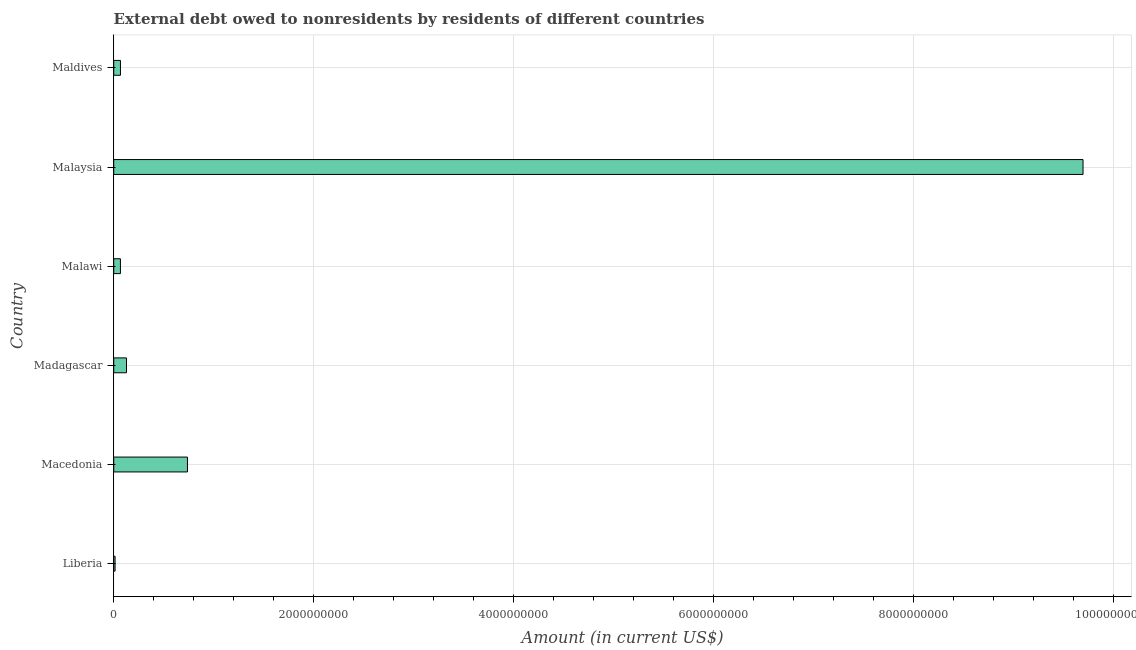Does the graph contain any zero values?
Your answer should be compact. No. What is the title of the graph?
Provide a succinct answer. External debt owed to nonresidents by residents of different countries. What is the label or title of the X-axis?
Make the answer very short. Amount (in current US$). What is the debt in Liberia?
Keep it short and to the point. 1.33e+07. Across all countries, what is the maximum debt?
Provide a short and direct response. 9.70e+09. Across all countries, what is the minimum debt?
Provide a succinct answer. 1.33e+07. In which country was the debt maximum?
Offer a very short reply. Malaysia. In which country was the debt minimum?
Offer a very short reply. Liberia. What is the sum of the debt?
Provide a succinct answer. 1.07e+1. What is the difference between the debt in Macedonia and Maldives?
Keep it short and to the point. 6.70e+08. What is the average debt per country?
Offer a terse response. 1.79e+09. What is the median debt?
Give a very brief answer. 9.73e+07. In how many countries, is the debt greater than 9600000000 US$?
Your response must be concise. 1. What is the ratio of the debt in Macedonia to that in Madagascar?
Keep it short and to the point. 5.79. Is the debt in Liberia less than that in Malaysia?
Your answer should be very brief. Yes. Is the difference between the debt in Madagascar and Maldives greater than the difference between any two countries?
Make the answer very short. No. What is the difference between the highest and the second highest debt?
Provide a short and direct response. 8.96e+09. What is the difference between the highest and the lowest debt?
Offer a terse response. 9.68e+09. What is the difference between two consecutive major ticks on the X-axis?
Give a very brief answer. 2.00e+09. What is the Amount (in current US$) in Liberia?
Provide a succinct answer. 1.33e+07. What is the Amount (in current US$) in Macedonia?
Your answer should be very brief. 7.37e+08. What is the Amount (in current US$) of Madagascar?
Your answer should be compact. 1.27e+08. What is the Amount (in current US$) in Malawi?
Make the answer very short. 6.69e+07. What is the Amount (in current US$) of Malaysia?
Your response must be concise. 9.70e+09. What is the Amount (in current US$) of Maldives?
Provide a succinct answer. 6.72e+07. What is the difference between the Amount (in current US$) in Liberia and Macedonia?
Make the answer very short. -7.24e+08. What is the difference between the Amount (in current US$) in Liberia and Madagascar?
Your answer should be very brief. -1.14e+08. What is the difference between the Amount (in current US$) in Liberia and Malawi?
Provide a succinct answer. -5.35e+07. What is the difference between the Amount (in current US$) in Liberia and Malaysia?
Your response must be concise. -9.68e+09. What is the difference between the Amount (in current US$) in Liberia and Maldives?
Your answer should be very brief. -5.39e+07. What is the difference between the Amount (in current US$) in Macedonia and Madagascar?
Your response must be concise. 6.10e+08. What is the difference between the Amount (in current US$) in Macedonia and Malawi?
Provide a succinct answer. 6.71e+08. What is the difference between the Amount (in current US$) in Macedonia and Malaysia?
Make the answer very short. -8.96e+09. What is the difference between the Amount (in current US$) in Macedonia and Maldives?
Ensure brevity in your answer.  6.70e+08. What is the difference between the Amount (in current US$) in Madagascar and Malawi?
Give a very brief answer. 6.05e+07. What is the difference between the Amount (in current US$) in Madagascar and Malaysia?
Keep it short and to the point. -9.57e+09. What is the difference between the Amount (in current US$) in Madagascar and Maldives?
Keep it short and to the point. 6.02e+07. What is the difference between the Amount (in current US$) in Malawi and Malaysia?
Offer a very short reply. -9.63e+09. What is the difference between the Amount (in current US$) in Malawi and Maldives?
Your response must be concise. -3.34e+05. What is the difference between the Amount (in current US$) in Malaysia and Maldives?
Provide a succinct answer. 9.63e+09. What is the ratio of the Amount (in current US$) in Liberia to that in Macedonia?
Your answer should be compact. 0.02. What is the ratio of the Amount (in current US$) in Liberia to that in Madagascar?
Provide a succinct answer. 0.1. What is the ratio of the Amount (in current US$) in Liberia to that in Malaysia?
Make the answer very short. 0. What is the ratio of the Amount (in current US$) in Liberia to that in Maldives?
Keep it short and to the point. 0.2. What is the ratio of the Amount (in current US$) in Macedonia to that in Madagascar?
Keep it short and to the point. 5.79. What is the ratio of the Amount (in current US$) in Macedonia to that in Malawi?
Provide a short and direct response. 11.03. What is the ratio of the Amount (in current US$) in Macedonia to that in Malaysia?
Provide a succinct answer. 0.08. What is the ratio of the Amount (in current US$) in Macedonia to that in Maldives?
Ensure brevity in your answer.  10.97. What is the ratio of the Amount (in current US$) in Madagascar to that in Malawi?
Provide a short and direct response. 1.91. What is the ratio of the Amount (in current US$) in Madagascar to that in Malaysia?
Ensure brevity in your answer.  0.01. What is the ratio of the Amount (in current US$) in Madagascar to that in Maldives?
Your answer should be very brief. 1.9. What is the ratio of the Amount (in current US$) in Malawi to that in Malaysia?
Make the answer very short. 0.01. What is the ratio of the Amount (in current US$) in Malaysia to that in Maldives?
Ensure brevity in your answer.  144.28. 